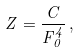Convert formula to latex. <formula><loc_0><loc_0><loc_500><loc_500>Z = \frac { C } { F _ { 0 } ^ { 4 } } \, ,</formula> 